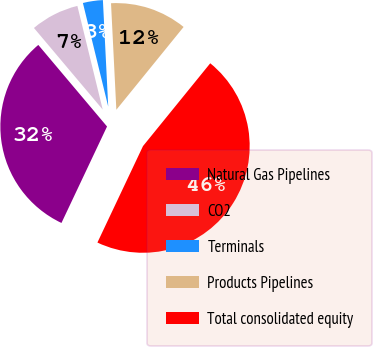Convert chart to OTSL. <chart><loc_0><loc_0><loc_500><loc_500><pie_chart><fcel>Natural Gas Pipelines<fcel>CO2<fcel>Terminals<fcel>Products Pipelines<fcel>Total consolidated equity<nl><fcel>31.83%<fcel>7.33%<fcel>3.02%<fcel>11.65%<fcel>46.17%<nl></chart> 